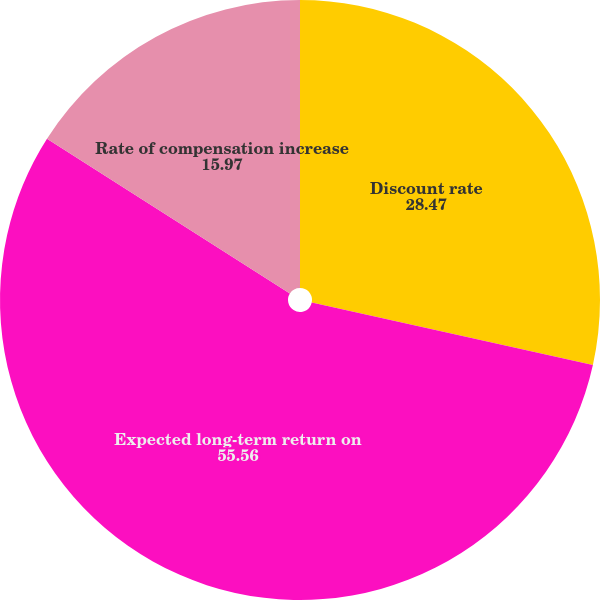Convert chart to OTSL. <chart><loc_0><loc_0><loc_500><loc_500><pie_chart><fcel>Discount rate<fcel>Expected long-term return on<fcel>Rate of compensation increase<nl><fcel>28.47%<fcel>55.56%<fcel>15.97%<nl></chart> 